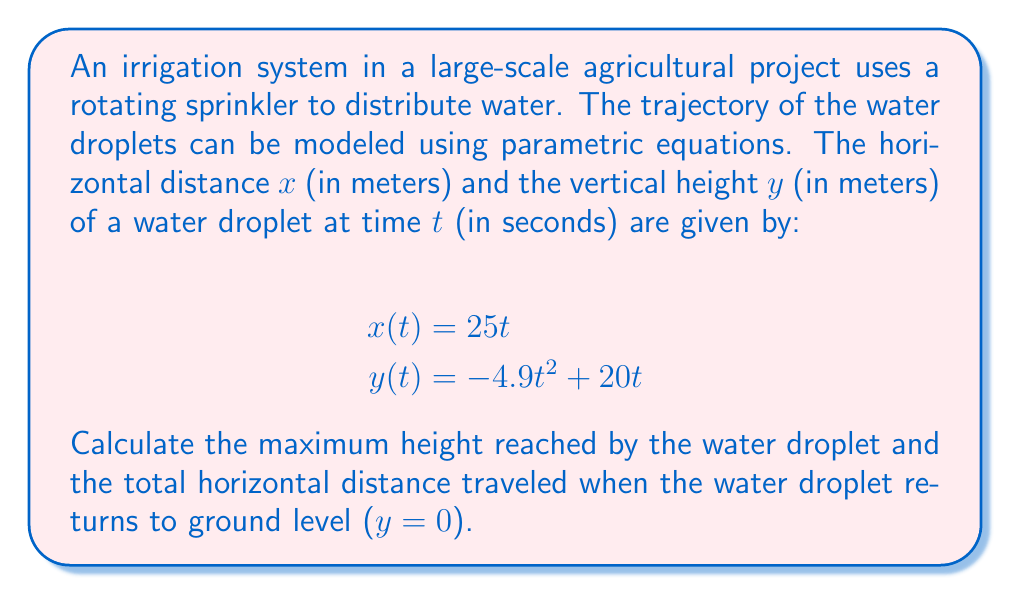What is the answer to this math problem? To solve this problem, we'll follow these steps:

1. Find the maximum height:
   The maximum height occurs when the vertical velocity is zero. We can find this by taking the derivative of $y(t)$ with respect to $t$ and setting it equal to zero.

   $$\frac{dy}{dt} = -9.8t + 20$$
   Set this equal to zero and solve for $t$:
   $$-9.8t + 20 = 0$$
   $$t = \frac{20}{9.8} \approx 2.04 \text{ seconds}$$

   Now, substitute this value of $t$ back into the equation for $y(t)$:
   $$y(2.04) = -4.9(2.04)^2 + 20(2.04) \approx 10.20 \text{ meters}$$

2. Find the total horizontal distance:
   To find when the water droplet returns to ground level, we need to solve the equation $y(t) = 0$:

   $$-4.9t^2 + 20t = 0$$
   $$t(-4.9t + 20) = 0$$

   This equation has two solutions: $t = 0$ (when the water leaves the sprinkler) and:
   $$-4.9t + 20 = 0$$
   $$t = \frac{20}{4.9} \approx 4.08 \text{ seconds}$$

   The total horizontal distance is found by substituting this time into the equation for $x(t)$:
   $$x(4.08) = 25(4.08) \approx 102 \text{ meters}$$
Answer: The maximum height reached by the water droplet is approximately 10.20 meters, and the total horizontal distance traveled is approximately 102 meters. 